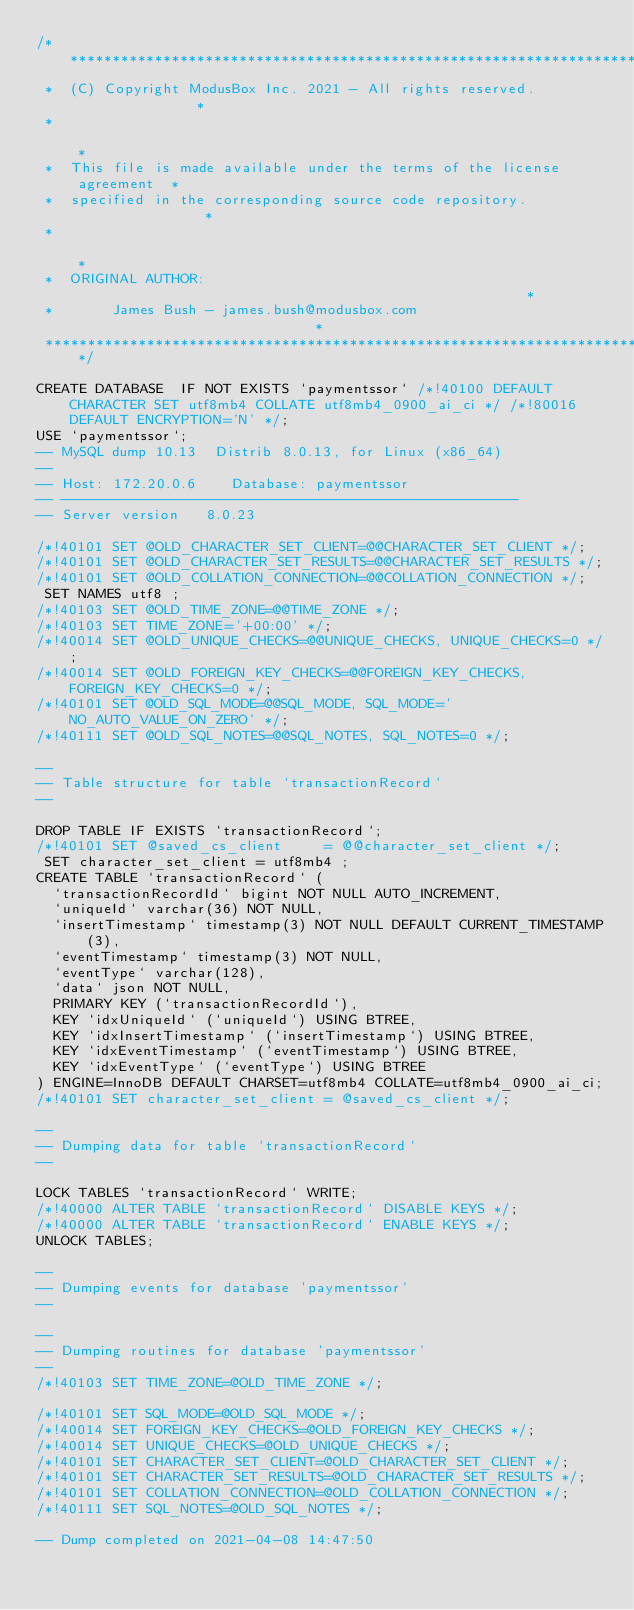Convert code to text. <code><loc_0><loc_0><loc_500><loc_500><_SQL_>/**************************************************************************
 *  (C) Copyright ModusBox Inc. 2021 - All rights reserved.               *
 *                                                                        *
 *  This file is made available under the terms of the license agreement  *
 *  specified in the corresponding source code repository.                *
 *                                                                        *
 *  ORIGINAL AUTHOR:                                                      *
 *       James Bush - james.bush@modusbox.com                             *
 **************************************************************************/

CREATE DATABASE  IF NOT EXISTS `paymentssor` /*!40100 DEFAULT CHARACTER SET utf8mb4 COLLATE utf8mb4_0900_ai_ci */ /*!80016 DEFAULT ENCRYPTION='N' */;
USE `paymentssor`;
-- MySQL dump 10.13  Distrib 8.0.13, for Linux (x86_64)
--
-- Host: 172.20.0.6    Database: paymentssor
-- ------------------------------------------------------
-- Server version   8.0.23

/*!40101 SET @OLD_CHARACTER_SET_CLIENT=@@CHARACTER_SET_CLIENT */;
/*!40101 SET @OLD_CHARACTER_SET_RESULTS=@@CHARACTER_SET_RESULTS */;
/*!40101 SET @OLD_COLLATION_CONNECTION=@@COLLATION_CONNECTION */;
 SET NAMES utf8 ;
/*!40103 SET @OLD_TIME_ZONE=@@TIME_ZONE */;
/*!40103 SET TIME_ZONE='+00:00' */;
/*!40014 SET @OLD_UNIQUE_CHECKS=@@UNIQUE_CHECKS, UNIQUE_CHECKS=0 */;
/*!40014 SET @OLD_FOREIGN_KEY_CHECKS=@@FOREIGN_KEY_CHECKS, FOREIGN_KEY_CHECKS=0 */;
/*!40101 SET @OLD_SQL_MODE=@@SQL_MODE, SQL_MODE='NO_AUTO_VALUE_ON_ZERO' */;
/*!40111 SET @OLD_SQL_NOTES=@@SQL_NOTES, SQL_NOTES=0 */;

--
-- Table structure for table `transactionRecord`
--

DROP TABLE IF EXISTS `transactionRecord`;
/*!40101 SET @saved_cs_client     = @@character_set_client */;
 SET character_set_client = utf8mb4 ;
CREATE TABLE `transactionRecord` (
  `transactionRecordId` bigint NOT NULL AUTO_INCREMENT,
  `uniqueId` varchar(36) NOT NULL,
  `insertTimestamp` timestamp(3) NOT NULL DEFAULT CURRENT_TIMESTAMP(3),
  `eventTimestamp` timestamp(3) NOT NULL,
  `eventType` varchar(128),
  `data` json NOT NULL,
  PRIMARY KEY (`transactionRecordId`),
  KEY `idxUniqueId` (`uniqueId`) USING BTREE,
  KEY `idxInsertTimestamp` (`insertTimestamp`) USING BTREE,
  KEY `idxEventTimestamp` (`eventTimestamp`) USING BTREE,
  KEY `idxEventType` (`eventType`) USING BTREE
) ENGINE=InnoDB DEFAULT CHARSET=utf8mb4 COLLATE=utf8mb4_0900_ai_ci;
/*!40101 SET character_set_client = @saved_cs_client */;

--
-- Dumping data for table `transactionRecord`
--

LOCK TABLES `transactionRecord` WRITE;
/*!40000 ALTER TABLE `transactionRecord` DISABLE KEYS */;
/*!40000 ALTER TABLE `transactionRecord` ENABLE KEYS */;
UNLOCK TABLES;

--
-- Dumping events for database 'paymentssor'
--

--
-- Dumping routines for database 'paymentssor'
--
/*!40103 SET TIME_ZONE=@OLD_TIME_ZONE */;

/*!40101 SET SQL_MODE=@OLD_SQL_MODE */;
/*!40014 SET FOREIGN_KEY_CHECKS=@OLD_FOREIGN_KEY_CHECKS */;
/*!40014 SET UNIQUE_CHECKS=@OLD_UNIQUE_CHECKS */;
/*!40101 SET CHARACTER_SET_CLIENT=@OLD_CHARACTER_SET_CLIENT */;
/*!40101 SET CHARACTER_SET_RESULTS=@OLD_CHARACTER_SET_RESULTS */;
/*!40101 SET COLLATION_CONNECTION=@OLD_COLLATION_CONNECTION */;
/*!40111 SET SQL_NOTES=@OLD_SQL_NOTES */;

-- Dump completed on 2021-04-08 14:47:50
</code> 